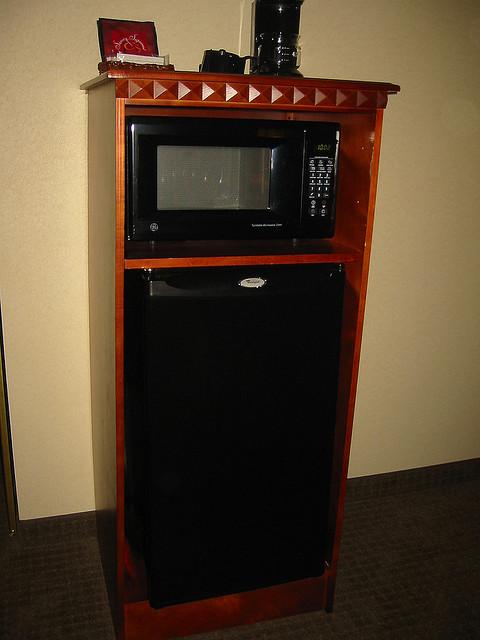What color are the appliances?
Short answer required. Black. Is there anything in the microwave?
Be succinct. No. Is this a television?
Be succinct. No. What object is this?
Quick response, please. Microwave. 